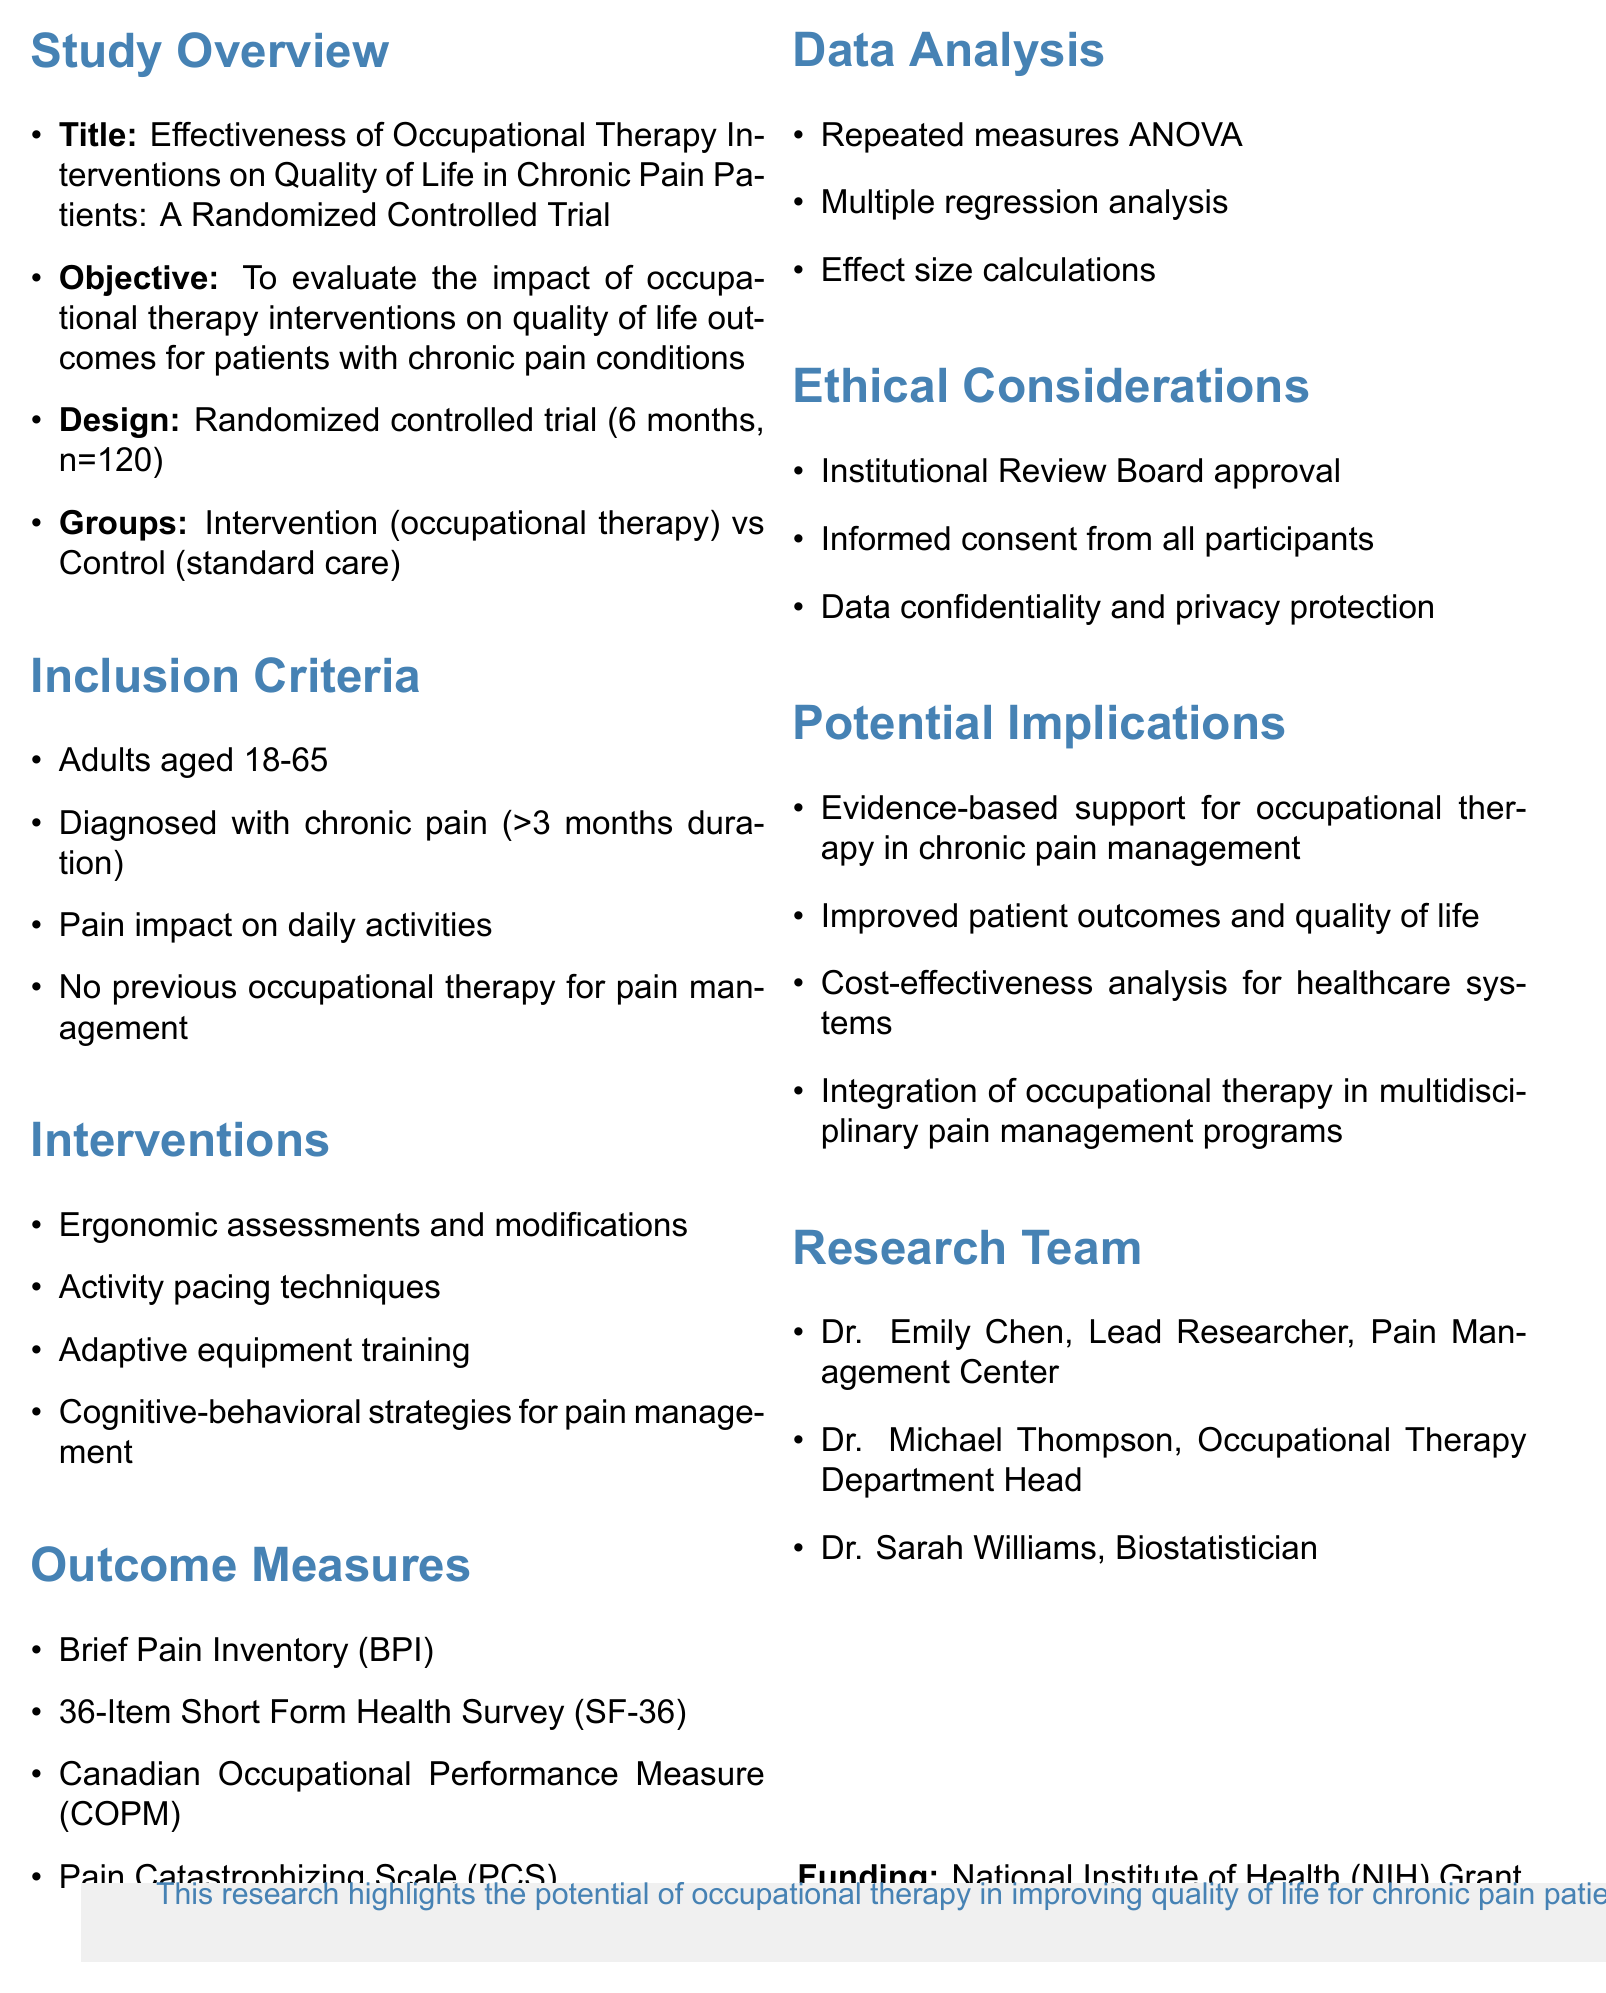what is the title of the study? The title of the study is provided in the document as the main title, which summarizes the focus of the research.
Answer: Effectiveness of Occupational Therapy Interventions on Quality of Life in Chronic Pain Patients: A Randomized Controlled Trial what is the sample size for the study? The sample size is a specific number detailing how many participants will be involved in the research, listed in the study overview.
Answer: 120 who is the lead researcher for the study? The lead researcher's name is mentioned alongside their role within the research team, indicating their main responsibility.
Answer: Dr. Emily Chen what design is utilized for the study? The design type explains how the research is structured, which is specifically stated in the study overview.
Answer: Randomized controlled trial what is one of the interventions used in the study? Interventions are listed and describe the methods that will be applied during the study, which can be found in the respective section.
Answer: Ergonomic assessments and modifications what outcome measure assesses pain in the study? Outcome measures are specified to evaluate the effects of the interventions, and one focuses on pain measurement.
Answer: Brief Pain Inventory (BPI) how long is the duration of the study? The duration of the study indicates how long the research will take place and is stated clearly in the study design section.
Answer: 6 months what is the funding source for the study? The source of funding explains how the study is financially supported and is clearly mentioned in the document.
Answer: National Institute of Health (NIH) Grant what ethical consideration is mentioned in the study? Ethical considerations are important for the research integrity and participant protection, outlined as part of the study's protocol.
Answer: Informed consent from all participants 